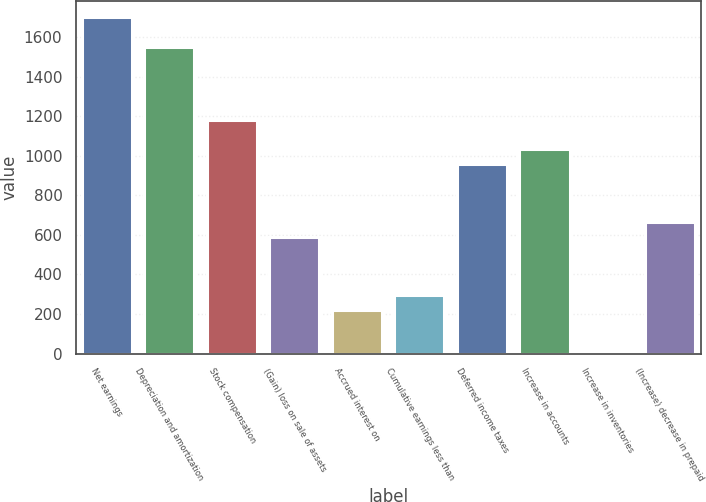Convert chart to OTSL. <chart><loc_0><loc_0><loc_500><loc_500><bar_chart><fcel>Net earnings<fcel>Depreciation and amortization<fcel>Stock compensation<fcel>(Gain) loss on sale of assets<fcel>Accrued interest on<fcel>Cumulative earnings less than<fcel>Deferred income taxes<fcel>Increase in accounts<fcel>Increase in inventories<fcel>(Increase) decrease in prepaid<nl><fcel>1699.31<fcel>1551.57<fcel>1182.22<fcel>591.26<fcel>221.91<fcel>295.78<fcel>960.61<fcel>1034.48<fcel>0.3<fcel>665.13<nl></chart> 